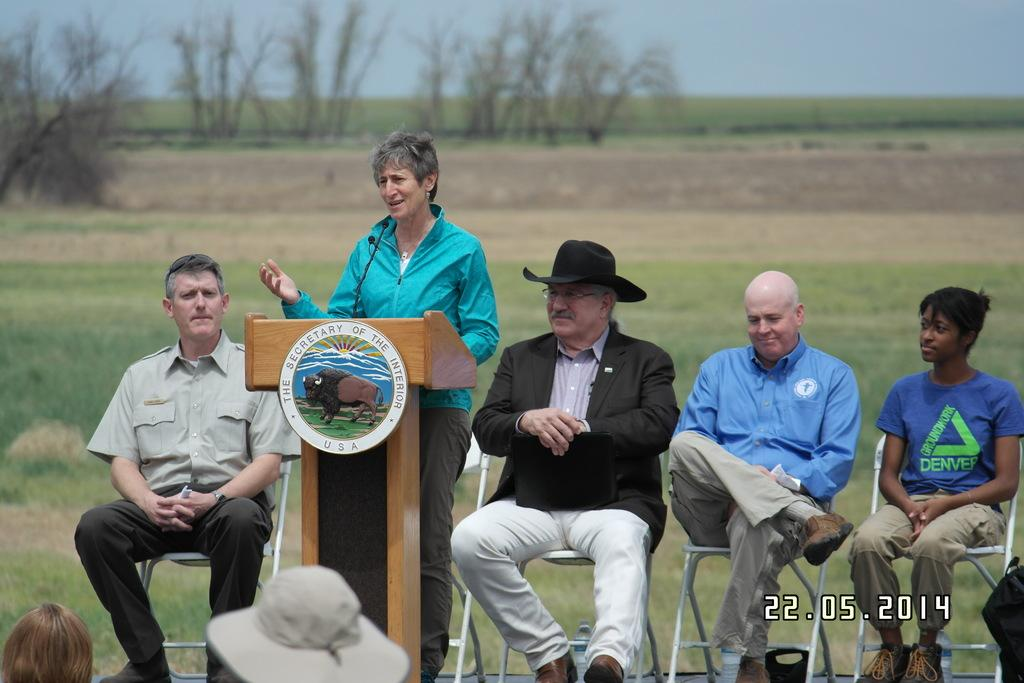How many people are sitting in the image? There are four people sitting on chairs in the image. What is in front of one of the people? There is a podium in front of one of the people. Can you describe the background of the image? The background is blurry, and trees are visible in the background. What objects are under the chairs? There are bottles under the chairs. How does the person with the podium spark a conversation with their ear? There is no mention of sparking a conversation or using an ear in the image; the person with the podium is simply standing in front of it. 